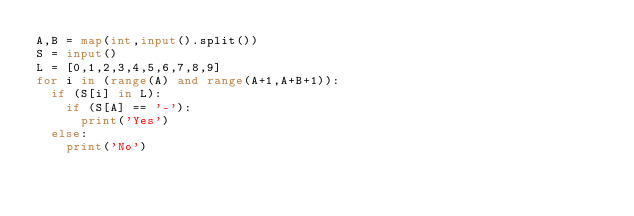Convert code to text. <code><loc_0><loc_0><loc_500><loc_500><_Python_>A,B = map(int,input().split())
S = input()
L = [0,1,2,3,4,5,6,7,8,9]
for i in (range(A) and range(A+1,A+B+1)):
  if (S[i] in L):
    if (S[A] == '-'):
      print('Yes')
  else:
    print('No')</code> 